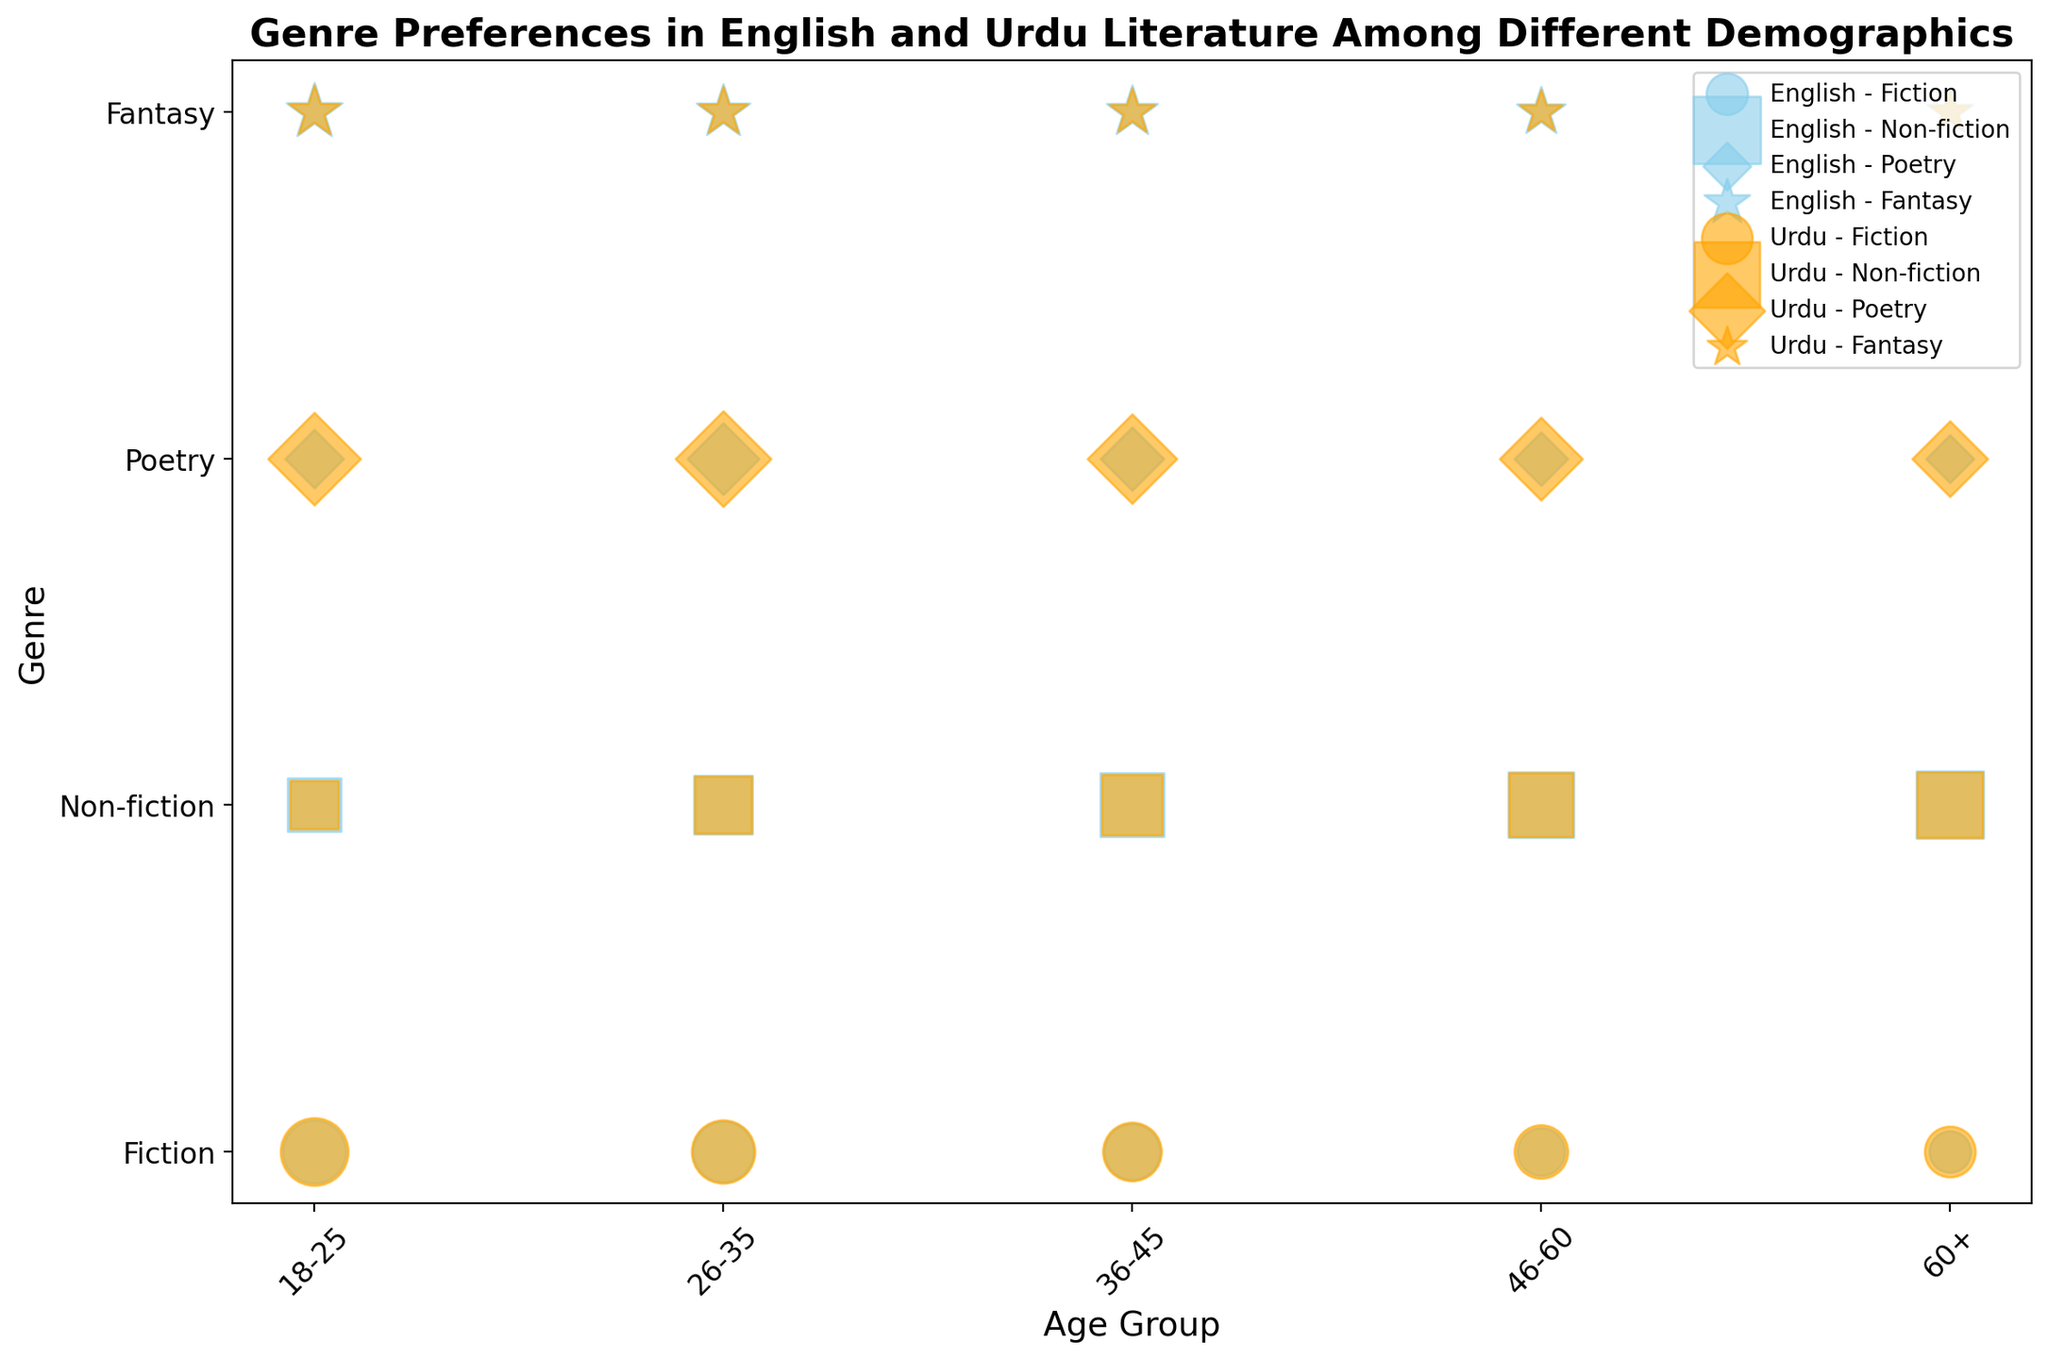Which genre has the highest preference level among 18-25 Urdu readers? Looking at the scatter points within the 18-25 age group for Urdu literature, the largest bubble corresponds to Poetry with a preference level of 75.
Answer: Poetry Do English readers aged 46-60 prefer Non-fiction or Fiction more? Comparing the scatter points for Fiction and Non-fiction in the 46-60 age group for English literature, the bubble for Non-fiction is larger, indicating a preference level of 75, while the bubble for Fiction has a preference level of 40.
Answer: Non-fiction What is the difference in preference levels for Fantasy between the 18-25 and 60+ Urdu readers? The bubble size for Fantasy among 18-25 Urdu readers shows a preference level of 50, while for 60+ Urdu readers, it’s 30. The difference is 50 - 30 = 20.
Answer: 20 Which age group has the highest preference level for English Non-fiction? Observing the scatter points across the age groups for English Non-fiction, the largest bubble is found in the 60+ age group, indicating the highest preference level of 80.
Answer: 60+ How does the preference for Poetry compare between 26-35 Urdu and 36-45 English readers? The bubbles for Poetry in the 26-35 Urdu and 36-45 English groups show levels of 80 and 35, respectively. Thus, 26-35 Urdu readers prefer Poetry significantly more than 36-45 English readers.
Answer: 26-35 Urdu What is the average preference level for Fiction among all age groups in English literature? The preference levels for Fiction in English across all age groups are 70, 65, 55, 40, and 30. Adding these values gives 70 + 65 + 55 + 40 + 30 = 260. There are 5 age groups, so the average is 260/5 = 52.
Answer: 52 Between the age groups 36-45 and 46-60, which one has a higher overall preference for Urdu literature genres? Summing the preference levels for the 36-45 age group in Urdu across all genres (60 + 65 + 70 + 40 = 235) and for the 46-60 age group (50 + 70 + 60 + 35 = 215) shows that the 36-45 age group has a higher overall preference.
Answer: 36-45 In which genre do 26-35 Urdu readers have the lowest preference, and what is that level? For 26-35 Urdu readers, the smallest bubble is found in the Fantasy genre, with a preference level of 45.
Answer: Fantasy, 45 Is there any genre where 26-35 readers prefer Urdu more than English in terms of preference levels? Comparing the same age group's preference levels for each genre, only Poetry shows a higher preference for Urdu (80) than English (45).
Answer: Poetry 